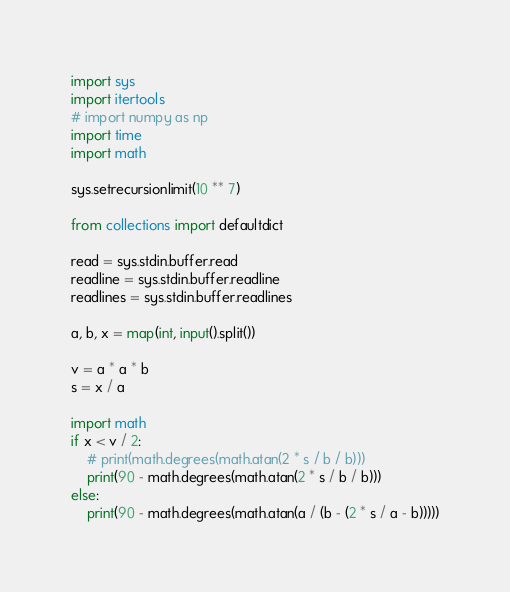<code> <loc_0><loc_0><loc_500><loc_500><_Python_>import sys
import itertools
# import numpy as np
import time
import math
 
sys.setrecursionlimit(10 ** 7)
 
from collections import defaultdict
 
read = sys.stdin.buffer.read
readline = sys.stdin.buffer.readline
readlines = sys.stdin.buffer.readlines

a, b, x = map(int, input().split())

v = a * a * b
s = x / a

import math
if x < v / 2:
    # print(math.degrees(math.atan(2 * s / b / b)))
    print(90 - math.degrees(math.atan(2 * s / b / b)))
else:
    print(90 - math.degrees(math.atan(a / (b - (2 * s / a - b)))))

</code> 